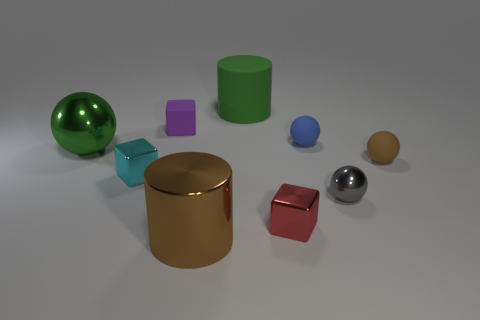Add 1 gray balls. How many objects exist? 10 Subtract all cubes. How many objects are left? 6 Subtract 0 brown blocks. How many objects are left? 9 Subtract all cyan objects. Subtract all blue things. How many objects are left? 7 Add 3 tiny purple cubes. How many tiny purple cubes are left? 4 Add 3 big green things. How many big green things exist? 5 